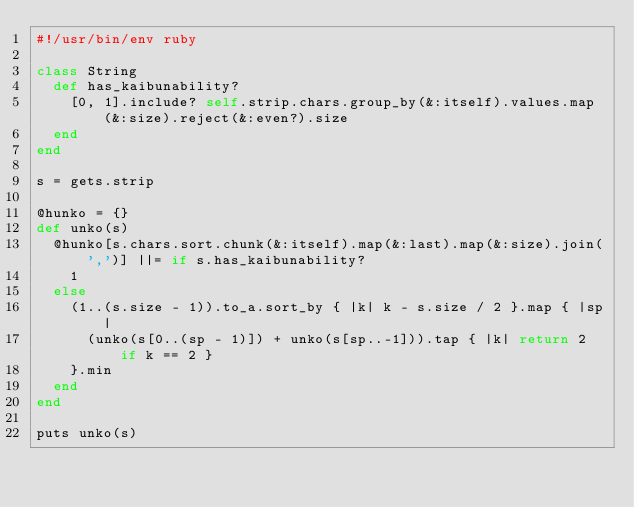<code> <loc_0><loc_0><loc_500><loc_500><_Ruby_>#!/usr/bin/env ruby

class String
  def has_kaibunability?
    [0, 1].include? self.strip.chars.group_by(&:itself).values.map(&:size).reject(&:even?).size
  end
end

s = gets.strip

@hunko = {}
def unko(s)
  @hunko[s.chars.sort.chunk(&:itself).map(&:last).map(&:size).join(',')] ||= if s.has_kaibunability?
    1
  else
    (1..(s.size - 1)).to_a.sort_by { |k| k - s.size / 2 }.map { |sp|
      (unko(s[0..(sp - 1)]) + unko(s[sp..-1])).tap { |k| return 2 if k == 2 }
    }.min
  end
end

puts unko(s)
</code> 